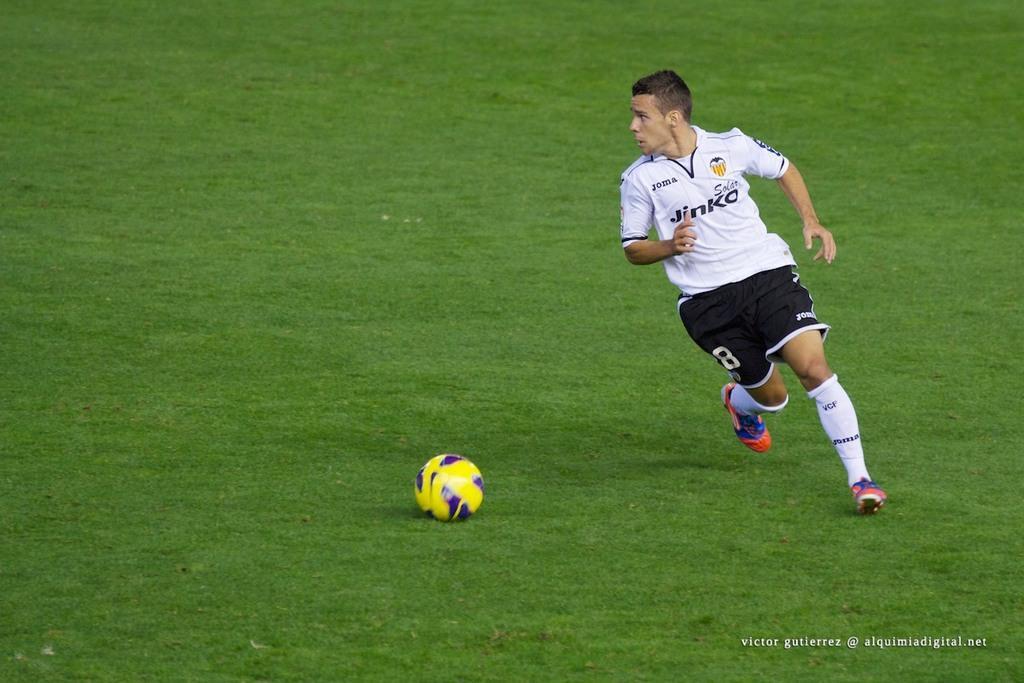Could you give a brief overview of what you see in this image? In the center of the image we can see person running and football on the ground. 